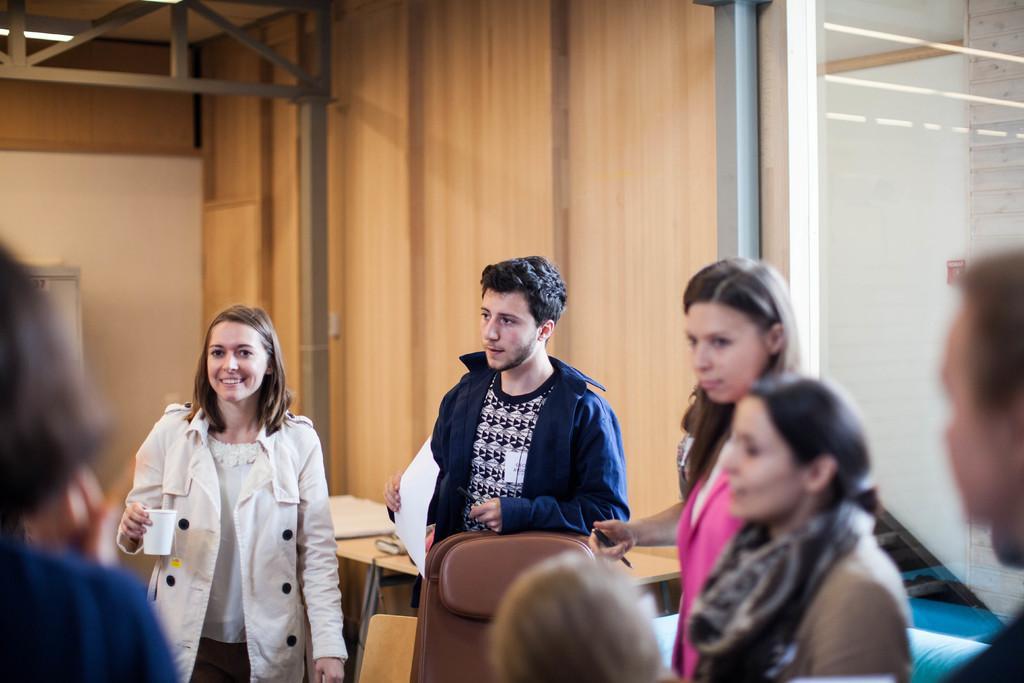Could you give a brief overview of what you see in this image? In this image there are people. Behind them there are tables. There are chairs. On the right side of the image there is a glass door. In the background of the image there is a wall. On top of the image there is a light and there are metal rods. 